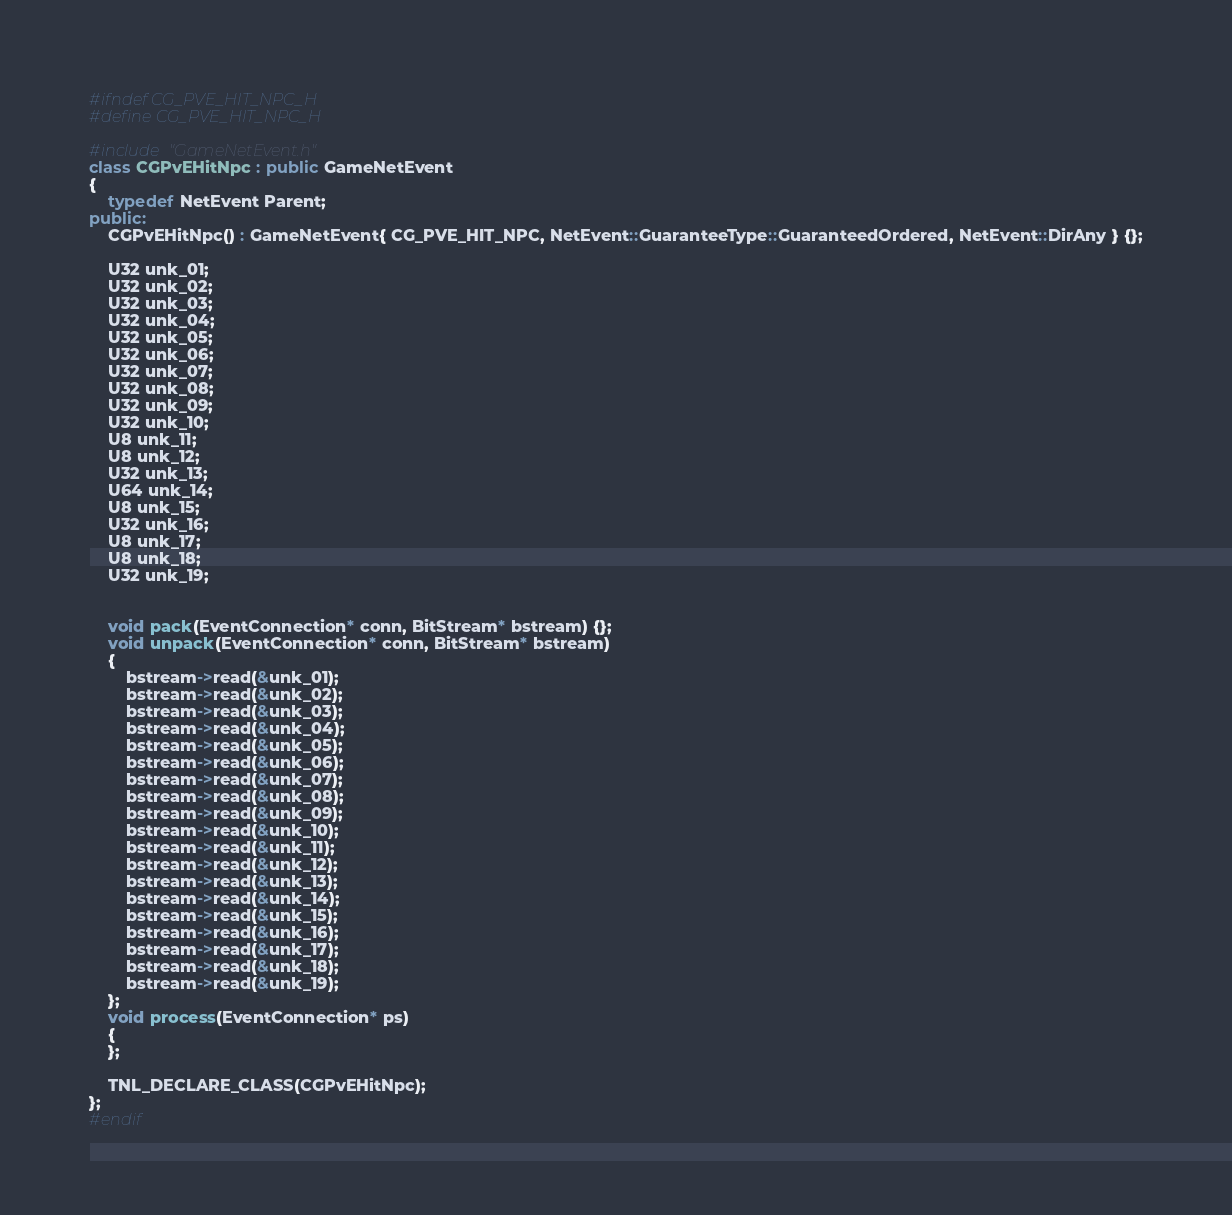<code> <loc_0><loc_0><loc_500><loc_500><_C++_>#ifndef CG_PVE_HIT_NPC_H
#define CG_PVE_HIT_NPC_H

#include "GameNetEvent.h"
class CGPvEHitNpc : public GameNetEvent
{
	typedef NetEvent Parent;
public:
	CGPvEHitNpc() : GameNetEvent{ CG_PVE_HIT_NPC, NetEvent::GuaranteeType::GuaranteedOrdered, NetEvent::DirAny } {};

	U32 unk_01;
	U32 unk_02;
	U32 unk_03;
	U32 unk_04;
	U32 unk_05;
	U32 unk_06;
	U32 unk_07;
	U32 unk_08;
	U32 unk_09;
	U32 unk_10;
	U8 unk_11;
	U8 unk_12;
	U32 unk_13;
	U64 unk_14;
	U8 unk_15;
	U32 unk_16;
	U8 unk_17;
	U8 unk_18;
	U32 unk_19;


	void pack(EventConnection* conn, BitStream* bstream) {};
	void unpack(EventConnection* conn, BitStream* bstream)
	{
		bstream->read(&unk_01);
		bstream->read(&unk_02);
		bstream->read(&unk_03);
		bstream->read(&unk_04);
		bstream->read(&unk_05);
		bstream->read(&unk_06);
		bstream->read(&unk_07);
		bstream->read(&unk_08);
		bstream->read(&unk_09);
		bstream->read(&unk_10);
		bstream->read(&unk_11);
		bstream->read(&unk_12);
		bstream->read(&unk_13);
		bstream->read(&unk_14);
		bstream->read(&unk_15);
		bstream->read(&unk_16);
		bstream->read(&unk_17);
		bstream->read(&unk_18);
		bstream->read(&unk_19);
	};
	void process(EventConnection* ps) 
	{
	};

	TNL_DECLARE_CLASS(CGPvEHitNpc);
};
#endif</code> 